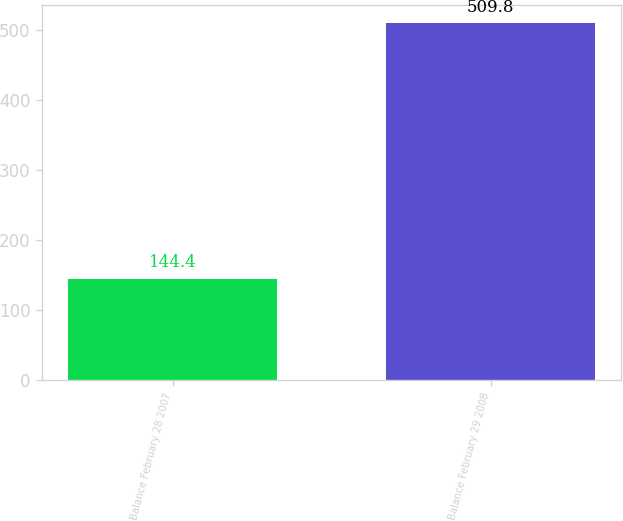Convert chart to OTSL. <chart><loc_0><loc_0><loc_500><loc_500><bar_chart><fcel>Balance February 28 2007<fcel>Balance February 29 2008<nl><fcel>144.4<fcel>509.8<nl></chart> 